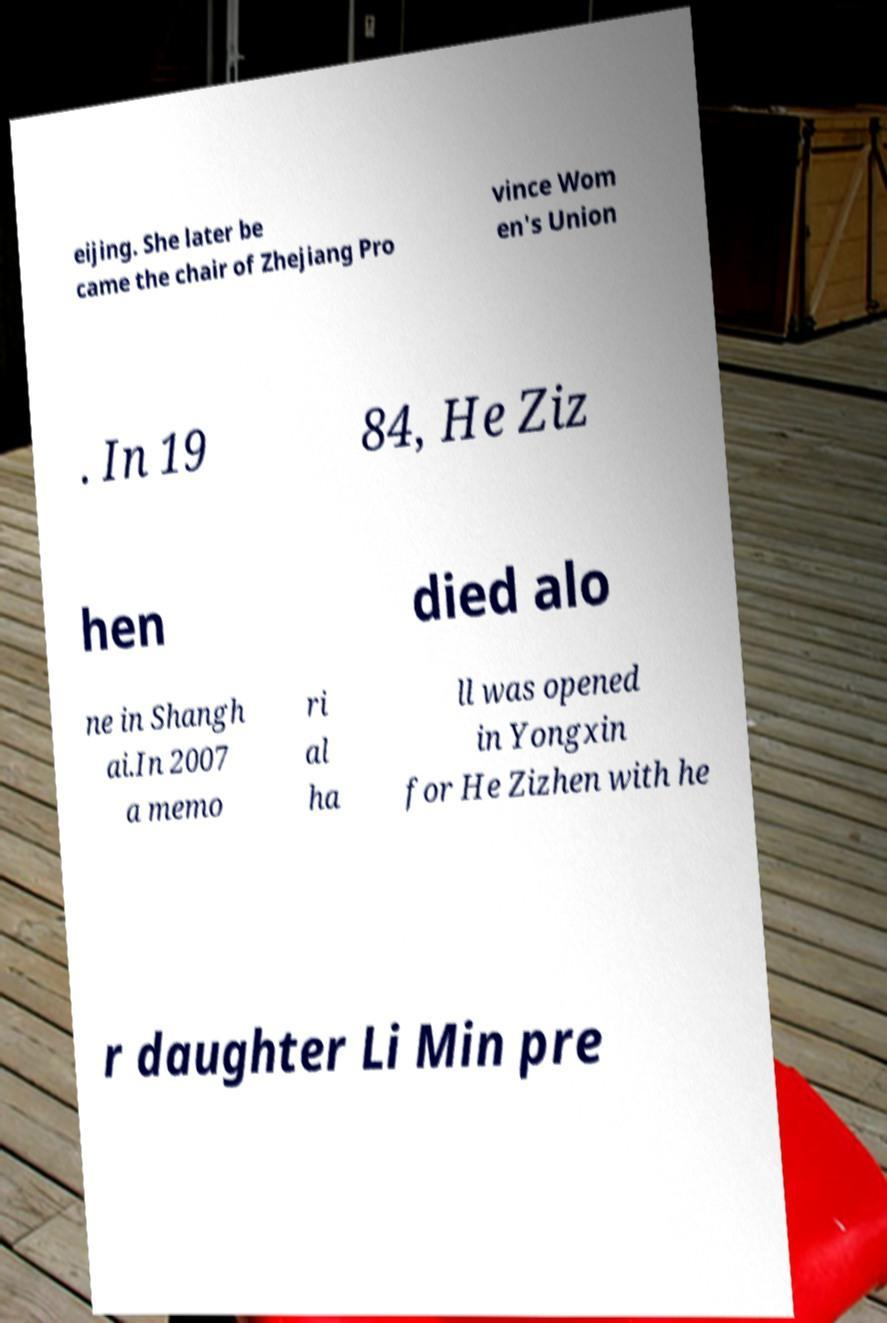Please identify and transcribe the text found in this image. eijing. She later be came the chair of Zhejiang Pro vince Wom en's Union . In 19 84, He Ziz hen died alo ne in Shangh ai.In 2007 a memo ri al ha ll was opened in Yongxin for He Zizhen with he r daughter Li Min pre 